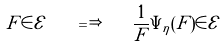<formula> <loc_0><loc_0><loc_500><loc_500>F \in \mathcal { E \quad } \Longrightarrow \quad \frac { 1 } { F } \Psi _ { \eta } ( F ) \in \mathcal { E }</formula> 